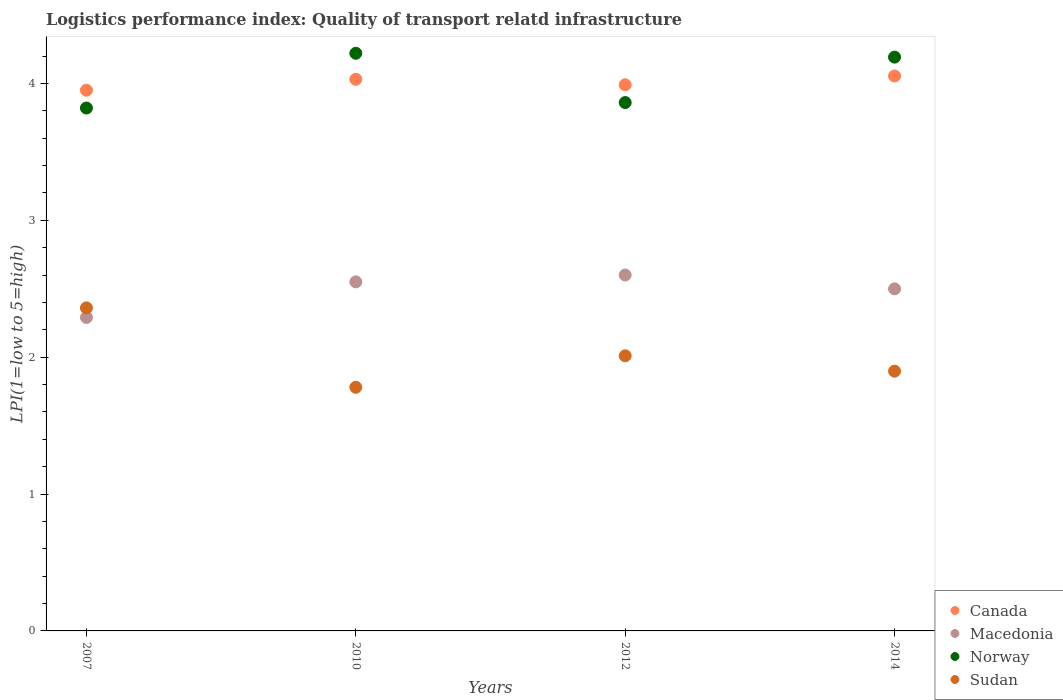How many different coloured dotlines are there?
Make the answer very short. 4. Is the number of dotlines equal to the number of legend labels?
Offer a very short reply. Yes. What is the logistics performance index in Canada in 2012?
Your answer should be very brief. 3.99. Across all years, what is the maximum logistics performance index in Canada?
Offer a terse response. 4.05. Across all years, what is the minimum logistics performance index in Norway?
Provide a succinct answer. 3.82. In which year was the logistics performance index in Sudan maximum?
Your answer should be compact. 2007. What is the total logistics performance index in Norway in the graph?
Your answer should be very brief. 16.09. What is the difference between the logistics performance index in Canada in 2007 and that in 2010?
Provide a short and direct response. -0.08. What is the difference between the logistics performance index in Norway in 2014 and the logistics performance index in Canada in 2012?
Offer a very short reply. 0.2. What is the average logistics performance index in Macedonia per year?
Your answer should be very brief. 2.48. In the year 2012, what is the difference between the logistics performance index in Macedonia and logistics performance index in Sudan?
Your answer should be compact. 0.59. In how many years, is the logistics performance index in Macedonia greater than 3.8?
Your response must be concise. 0. What is the ratio of the logistics performance index in Canada in 2007 to that in 2010?
Keep it short and to the point. 0.98. Is the logistics performance index in Norway in 2010 less than that in 2014?
Your answer should be compact. No. What is the difference between the highest and the second highest logistics performance index in Canada?
Your answer should be very brief. 0.02. What is the difference between the highest and the lowest logistics performance index in Sudan?
Offer a terse response. 0.58. In how many years, is the logistics performance index in Norway greater than the average logistics performance index in Norway taken over all years?
Provide a short and direct response. 2. Is the sum of the logistics performance index in Canada in 2010 and 2012 greater than the maximum logistics performance index in Norway across all years?
Your answer should be very brief. Yes. Is it the case that in every year, the sum of the logistics performance index in Canada and logistics performance index in Norway  is greater than the logistics performance index in Sudan?
Give a very brief answer. Yes. Is the logistics performance index in Norway strictly greater than the logistics performance index in Canada over the years?
Offer a terse response. No. How many dotlines are there?
Offer a very short reply. 4. How many years are there in the graph?
Offer a terse response. 4. Does the graph contain grids?
Ensure brevity in your answer.  No. Where does the legend appear in the graph?
Ensure brevity in your answer.  Bottom right. How are the legend labels stacked?
Keep it short and to the point. Vertical. What is the title of the graph?
Ensure brevity in your answer.  Logistics performance index: Quality of transport relatd infrastructure. Does "Ghana" appear as one of the legend labels in the graph?
Ensure brevity in your answer.  No. What is the label or title of the X-axis?
Keep it short and to the point. Years. What is the label or title of the Y-axis?
Offer a terse response. LPI(1=low to 5=high). What is the LPI(1=low to 5=high) of Canada in 2007?
Provide a succinct answer. 3.95. What is the LPI(1=low to 5=high) of Macedonia in 2007?
Provide a succinct answer. 2.29. What is the LPI(1=low to 5=high) in Norway in 2007?
Make the answer very short. 3.82. What is the LPI(1=low to 5=high) of Sudan in 2007?
Your answer should be very brief. 2.36. What is the LPI(1=low to 5=high) in Canada in 2010?
Offer a terse response. 4.03. What is the LPI(1=low to 5=high) in Macedonia in 2010?
Your answer should be compact. 2.55. What is the LPI(1=low to 5=high) of Norway in 2010?
Provide a succinct answer. 4.22. What is the LPI(1=low to 5=high) of Sudan in 2010?
Offer a terse response. 1.78. What is the LPI(1=low to 5=high) in Canada in 2012?
Provide a succinct answer. 3.99. What is the LPI(1=low to 5=high) of Macedonia in 2012?
Give a very brief answer. 2.6. What is the LPI(1=low to 5=high) of Norway in 2012?
Give a very brief answer. 3.86. What is the LPI(1=low to 5=high) in Sudan in 2012?
Provide a succinct answer. 2.01. What is the LPI(1=low to 5=high) in Canada in 2014?
Ensure brevity in your answer.  4.05. What is the LPI(1=low to 5=high) of Macedonia in 2014?
Offer a terse response. 2.5. What is the LPI(1=low to 5=high) in Norway in 2014?
Give a very brief answer. 4.19. What is the LPI(1=low to 5=high) of Sudan in 2014?
Offer a terse response. 1.9. Across all years, what is the maximum LPI(1=low to 5=high) in Canada?
Your answer should be compact. 4.05. Across all years, what is the maximum LPI(1=low to 5=high) of Macedonia?
Ensure brevity in your answer.  2.6. Across all years, what is the maximum LPI(1=low to 5=high) in Norway?
Ensure brevity in your answer.  4.22. Across all years, what is the maximum LPI(1=low to 5=high) in Sudan?
Offer a very short reply. 2.36. Across all years, what is the minimum LPI(1=low to 5=high) in Canada?
Your response must be concise. 3.95. Across all years, what is the minimum LPI(1=low to 5=high) of Macedonia?
Give a very brief answer. 2.29. Across all years, what is the minimum LPI(1=low to 5=high) in Norway?
Keep it short and to the point. 3.82. Across all years, what is the minimum LPI(1=low to 5=high) in Sudan?
Offer a very short reply. 1.78. What is the total LPI(1=low to 5=high) of Canada in the graph?
Provide a succinct answer. 16.02. What is the total LPI(1=low to 5=high) of Macedonia in the graph?
Give a very brief answer. 9.94. What is the total LPI(1=low to 5=high) in Norway in the graph?
Your answer should be compact. 16.09. What is the total LPI(1=low to 5=high) of Sudan in the graph?
Ensure brevity in your answer.  8.05. What is the difference between the LPI(1=low to 5=high) in Canada in 2007 and that in 2010?
Offer a terse response. -0.08. What is the difference between the LPI(1=low to 5=high) in Macedonia in 2007 and that in 2010?
Keep it short and to the point. -0.26. What is the difference between the LPI(1=low to 5=high) of Norway in 2007 and that in 2010?
Your answer should be very brief. -0.4. What is the difference between the LPI(1=low to 5=high) of Sudan in 2007 and that in 2010?
Make the answer very short. 0.58. What is the difference between the LPI(1=low to 5=high) of Canada in 2007 and that in 2012?
Provide a succinct answer. -0.04. What is the difference between the LPI(1=low to 5=high) in Macedonia in 2007 and that in 2012?
Offer a very short reply. -0.31. What is the difference between the LPI(1=low to 5=high) in Norway in 2007 and that in 2012?
Keep it short and to the point. -0.04. What is the difference between the LPI(1=low to 5=high) of Canada in 2007 and that in 2014?
Your response must be concise. -0.1. What is the difference between the LPI(1=low to 5=high) of Macedonia in 2007 and that in 2014?
Provide a short and direct response. -0.21. What is the difference between the LPI(1=low to 5=high) in Norway in 2007 and that in 2014?
Make the answer very short. -0.37. What is the difference between the LPI(1=low to 5=high) of Sudan in 2007 and that in 2014?
Keep it short and to the point. 0.46. What is the difference between the LPI(1=low to 5=high) in Norway in 2010 and that in 2012?
Offer a very short reply. 0.36. What is the difference between the LPI(1=low to 5=high) in Sudan in 2010 and that in 2012?
Your answer should be very brief. -0.23. What is the difference between the LPI(1=low to 5=high) in Canada in 2010 and that in 2014?
Ensure brevity in your answer.  -0.02. What is the difference between the LPI(1=low to 5=high) of Macedonia in 2010 and that in 2014?
Provide a short and direct response. 0.05. What is the difference between the LPI(1=low to 5=high) of Norway in 2010 and that in 2014?
Your answer should be compact. 0.03. What is the difference between the LPI(1=low to 5=high) in Sudan in 2010 and that in 2014?
Your response must be concise. -0.12. What is the difference between the LPI(1=low to 5=high) in Canada in 2012 and that in 2014?
Ensure brevity in your answer.  -0.06. What is the difference between the LPI(1=low to 5=high) in Macedonia in 2012 and that in 2014?
Your answer should be compact. 0.1. What is the difference between the LPI(1=low to 5=high) in Norway in 2012 and that in 2014?
Give a very brief answer. -0.33. What is the difference between the LPI(1=low to 5=high) in Sudan in 2012 and that in 2014?
Provide a succinct answer. 0.11. What is the difference between the LPI(1=low to 5=high) in Canada in 2007 and the LPI(1=low to 5=high) in Macedonia in 2010?
Your response must be concise. 1.4. What is the difference between the LPI(1=low to 5=high) of Canada in 2007 and the LPI(1=low to 5=high) of Norway in 2010?
Provide a succinct answer. -0.27. What is the difference between the LPI(1=low to 5=high) of Canada in 2007 and the LPI(1=low to 5=high) of Sudan in 2010?
Your response must be concise. 2.17. What is the difference between the LPI(1=low to 5=high) of Macedonia in 2007 and the LPI(1=low to 5=high) of Norway in 2010?
Offer a terse response. -1.93. What is the difference between the LPI(1=low to 5=high) of Macedonia in 2007 and the LPI(1=low to 5=high) of Sudan in 2010?
Ensure brevity in your answer.  0.51. What is the difference between the LPI(1=low to 5=high) of Norway in 2007 and the LPI(1=low to 5=high) of Sudan in 2010?
Your answer should be very brief. 2.04. What is the difference between the LPI(1=low to 5=high) of Canada in 2007 and the LPI(1=low to 5=high) of Macedonia in 2012?
Ensure brevity in your answer.  1.35. What is the difference between the LPI(1=low to 5=high) in Canada in 2007 and the LPI(1=low to 5=high) in Norway in 2012?
Your answer should be compact. 0.09. What is the difference between the LPI(1=low to 5=high) of Canada in 2007 and the LPI(1=low to 5=high) of Sudan in 2012?
Make the answer very short. 1.94. What is the difference between the LPI(1=low to 5=high) in Macedonia in 2007 and the LPI(1=low to 5=high) in Norway in 2012?
Your answer should be compact. -1.57. What is the difference between the LPI(1=low to 5=high) of Macedonia in 2007 and the LPI(1=low to 5=high) of Sudan in 2012?
Provide a short and direct response. 0.28. What is the difference between the LPI(1=low to 5=high) of Norway in 2007 and the LPI(1=low to 5=high) of Sudan in 2012?
Give a very brief answer. 1.81. What is the difference between the LPI(1=low to 5=high) of Canada in 2007 and the LPI(1=low to 5=high) of Macedonia in 2014?
Provide a succinct answer. 1.45. What is the difference between the LPI(1=low to 5=high) of Canada in 2007 and the LPI(1=low to 5=high) of Norway in 2014?
Provide a short and direct response. -0.24. What is the difference between the LPI(1=low to 5=high) of Canada in 2007 and the LPI(1=low to 5=high) of Sudan in 2014?
Give a very brief answer. 2.05. What is the difference between the LPI(1=low to 5=high) of Macedonia in 2007 and the LPI(1=low to 5=high) of Norway in 2014?
Give a very brief answer. -1.9. What is the difference between the LPI(1=low to 5=high) of Macedonia in 2007 and the LPI(1=low to 5=high) of Sudan in 2014?
Your answer should be very brief. 0.39. What is the difference between the LPI(1=low to 5=high) in Norway in 2007 and the LPI(1=low to 5=high) in Sudan in 2014?
Your answer should be compact. 1.92. What is the difference between the LPI(1=low to 5=high) in Canada in 2010 and the LPI(1=low to 5=high) in Macedonia in 2012?
Provide a succinct answer. 1.43. What is the difference between the LPI(1=low to 5=high) in Canada in 2010 and the LPI(1=low to 5=high) in Norway in 2012?
Provide a succinct answer. 0.17. What is the difference between the LPI(1=low to 5=high) of Canada in 2010 and the LPI(1=low to 5=high) of Sudan in 2012?
Give a very brief answer. 2.02. What is the difference between the LPI(1=low to 5=high) in Macedonia in 2010 and the LPI(1=low to 5=high) in Norway in 2012?
Your response must be concise. -1.31. What is the difference between the LPI(1=low to 5=high) of Macedonia in 2010 and the LPI(1=low to 5=high) of Sudan in 2012?
Your response must be concise. 0.54. What is the difference between the LPI(1=low to 5=high) of Norway in 2010 and the LPI(1=low to 5=high) of Sudan in 2012?
Keep it short and to the point. 2.21. What is the difference between the LPI(1=low to 5=high) of Canada in 2010 and the LPI(1=low to 5=high) of Macedonia in 2014?
Keep it short and to the point. 1.53. What is the difference between the LPI(1=low to 5=high) in Canada in 2010 and the LPI(1=low to 5=high) in Norway in 2014?
Give a very brief answer. -0.16. What is the difference between the LPI(1=low to 5=high) of Canada in 2010 and the LPI(1=low to 5=high) of Sudan in 2014?
Your answer should be very brief. 2.13. What is the difference between the LPI(1=low to 5=high) of Macedonia in 2010 and the LPI(1=low to 5=high) of Norway in 2014?
Your answer should be compact. -1.64. What is the difference between the LPI(1=low to 5=high) in Macedonia in 2010 and the LPI(1=low to 5=high) in Sudan in 2014?
Keep it short and to the point. 0.65. What is the difference between the LPI(1=low to 5=high) in Norway in 2010 and the LPI(1=low to 5=high) in Sudan in 2014?
Your answer should be very brief. 2.32. What is the difference between the LPI(1=low to 5=high) of Canada in 2012 and the LPI(1=low to 5=high) of Macedonia in 2014?
Offer a terse response. 1.49. What is the difference between the LPI(1=low to 5=high) in Canada in 2012 and the LPI(1=low to 5=high) in Norway in 2014?
Make the answer very short. -0.2. What is the difference between the LPI(1=low to 5=high) of Canada in 2012 and the LPI(1=low to 5=high) of Sudan in 2014?
Offer a very short reply. 2.09. What is the difference between the LPI(1=low to 5=high) in Macedonia in 2012 and the LPI(1=low to 5=high) in Norway in 2014?
Ensure brevity in your answer.  -1.59. What is the difference between the LPI(1=low to 5=high) in Macedonia in 2012 and the LPI(1=low to 5=high) in Sudan in 2014?
Keep it short and to the point. 0.7. What is the difference between the LPI(1=low to 5=high) in Norway in 2012 and the LPI(1=low to 5=high) in Sudan in 2014?
Provide a succinct answer. 1.96. What is the average LPI(1=low to 5=high) of Canada per year?
Make the answer very short. 4.01. What is the average LPI(1=low to 5=high) in Macedonia per year?
Provide a succinct answer. 2.48. What is the average LPI(1=low to 5=high) of Norway per year?
Your answer should be very brief. 4.02. What is the average LPI(1=low to 5=high) in Sudan per year?
Your response must be concise. 2.01. In the year 2007, what is the difference between the LPI(1=low to 5=high) of Canada and LPI(1=low to 5=high) of Macedonia?
Ensure brevity in your answer.  1.66. In the year 2007, what is the difference between the LPI(1=low to 5=high) in Canada and LPI(1=low to 5=high) in Norway?
Give a very brief answer. 0.13. In the year 2007, what is the difference between the LPI(1=low to 5=high) in Canada and LPI(1=low to 5=high) in Sudan?
Your answer should be compact. 1.59. In the year 2007, what is the difference between the LPI(1=low to 5=high) of Macedonia and LPI(1=low to 5=high) of Norway?
Your response must be concise. -1.53. In the year 2007, what is the difference between the LPI(1=low to 5=high) of Macedonia and LPI(1=low to 5=high) of Sudan?
Offer a very short reply. -0.07. In the year 2007, what is the difference between the LPI(1=low to 5=high) of Norway and LPI(1=low to 5=high) of Sudan?
Ensure brevity in your answer.  1.46. In the year 2010, what is the difference between the LPI(1=low to 5=high) in Canada and LPI(1=low to 5=high) in Macedonia?
Make the answer very short. 1.48. In the year 2010, what is the difference between the LPI(1=low to 5=high) in Canada and LPI(1=low to 5=high) in Norway?
Ensure brevity in your answer.  -0.19. In the year 2010, what is the difference between the LPI(1=low to 5=high) of Canada and LPI(1=low to 5=high) of Sudan?
Provide a short and direct response. 2.25. In the year 2010, what is the difference between the LPI(1=low to 5=high) in Macedonia and LPI(1=low to 5=high) in Norway?
Give a very brief answer. -1.67. In the year 2010, what is the difference between the LPI(1=low to 5=high) of Macedonia and LPI(1=low to 5=high) of Sudan?
Provide a short and direct response. 0.77. In the year 2010, what is the difference between the LPI(1=low to 5=high) in Norway and LPI(1=low to 5=high) in Sudan?
Your response must be concise. 2.44. In the year 2012, what is the difference between the LPI(1=low to 5=high) in Canada and LPI(1=low to 5=high) in Macedonia?
Your response must be concise. 1.39. In the year 2012, what is the difference between the LPI(1=low to 5=high) in Canada and LPI(1=low to 5=high) in Norway?
Offer a terse response. 0.13. In the year 2012, what is the difference between the LPI(1=low to 5=high) in Canada and LPI(1=low to 5=high) in Sudan?
Your answer should be compact. 1.98. In the year 2012, what is the difference between the LPI(1=low to 5=high) in Macedonia and LPI(1=low to 5=high) in Norway?
Your answer should be very brief. -1.26. In the year 2012, what is the difference between the LPI(1=low to 5=high) of Macedonia and LPI(1=low to 5=high) of Sudan?
Your answer should be compact. 0.59. In the year 2012, what is the difference between the LPI(1=low to 5=high) of Norway and LPI(1=low to 5=high) of Sudan?
Offer a terse response. 1.85. In the year 2014, what is the difference between the LPI(1=low to 5=high) in Canada and LPI(1=low to 5=high) in Macedonia?
Give a very brief answer. 1.56. In the year 2014, what is the difference between the LPI(1=low to 5=high) in Canada and LPI(1=low to 5=high) in Norway?
Make the answer very short. -0.14. In the year 2014, what is the difference between the LPI(1=low to 5=high) of Canada and LPI(1=low to 5=high) of Sudan?
Your response must be concise. 2.16. In the year 2014, what is the difference between the LPI(1=low to 5=high) in Macedonia and LPI(1=low to 5=high) in Norway?
Offer a very short reply. -1.69. In the year 2014, what is the difference between the LPI(1=low to 5=high) in Macedonia and LPI(1=low to 5=high) in Sudan?
Your answer should be very brief. 0.6. In the year 2014, what is the difference between the LPI(1=low to 5=high) in Norway and LPI(1=low to 5=high) in Sudan?
Keep it short and to the point. 2.29. What is the ratio of the LPI(1=low to 5=high) in Canada in 2007 to that in 2010?
Offer a very short reply. 0.98. What is the ratio of the LPI(1=low to 5=high) in Macedonia in 2007 to that in 2010?
Your answer should be compact. 0.9. What is the ratio of the LPI(1=low to 5=high) of Norway in 2007 to that in 2010?
Offer a very short reply. 0.91. What is the ratio of the LPI(1=low to 5=high) of Sudan in 2007 to that in 2010?
Provide a succinct answer. 1.33. What is the ratio of the LPI(1=low to 5=high) in Macedonia in 2007 to that in 2012?
Keep it short and to the point. 0.88. What is the ratio of the LPI(1=low to 5=high) of Norway in 2007 to that in 2012?
Your answer should be compact. 0.99. What is the ratio of the LPI(1=low to 5=high) in Sudan in 2007 to that in 2012?
Provide a succinct answer. 1.17. What is the ratio of the LPI(1=low to 5=high) of Canada in 2007 to that in 2014?
Your answer should be very brief. 0.97. What is the ratio of the LPI(1=low to 5=high) in Macedonia in 2007 to that in 2014?
Make the answer very short. 0.92. What is the ratio of the LPI(1=low to 5=high) in Norway in 2007 to that in 2014?
Your response must be concise. 0.91. What is the ratio of the LPI(1=low to 5=high) of Sudan in 2007 to that in 2014?
Offer a terse response. 1.24. What is the ratio of the LPI(1=low to 5=high) in Canada in 2010 to that in 2012?
Your answer should be very brief. 1.01. What is the ratio of the LPI(1=low to 5=high) in Macedonia in 2010 to that in 2012?
Ensure brevity in your answer.  0.98. What is the ratio of the LPI(1=low to 5=high) of Norway in 2010 to that in 2012?
Offer a terse response. 1.09. What is the ratio of the LPI(1=low to 5=high) in Sudan in 2010 to that in 2012?
Your answer should be very brief. 0.89. What is the ratio of the LPI(1=low to 5=high) of Canada in 2010 to that in 2014?
Offer a terse response. 0.99. What is the ratio of the LPI(1=low to 5=high) in Macedonia in 2010 to that in 2014?
Provide a succinct answer. 1.02. What is the ratio of the LPI(1=low to 5=high) of Norway in 2010 to that in 2014?
Keep it short and to the point. 1.01. What is the ratio of the LPI(1=low to 5=high) of Sudan in 2010 to that in 2014?
Offer a very short reply. 0.94. What is the ratio of the LPI(1=low to 5=high) of Canada in 2012 to that in 2014?
Provide a succinct answer. 0.98. What is the ratio of the LPI(1=low to 5=high) in Macedonia in 2012 to that in 2014?
Offer a terse response. 1.04. What is the ratio of the LPI(1=low to 5=high) of Norway in 2012 to that in 2014?
Ensure brevity in your answer.  0.92. What is the ratio of the LPI(1=low to 5=high) of Sudan in 2012 to that in 2014?
Give a very brief answer. 1.06. What is the difference between the highest and the second highest LPI(1=low to 5=high) in Canada?
Offer a very short reply. 0.02. What is the difference between the highest and the second highest LPI(1=low to 5=high) of Macedonia?
Give a very brief answer. 0.05. What is the difference between the highest and the second highest LPI(1=low to 5=high) in Norway?
Your response must be concise. 0.03. What is the difference between the highest and the lowest LPI(1=low to 5=high) in Canada?
Ensure brevity in your answer.  0.1. What is the difference between the highest and the lowest LPI(1=low to 5=high) of Macedonia?
Make the answer very short. 0.31. What is the difference between the highest and the lowest LPI(1=low to 5=high) of Sudan?
Your answer should be compact. 0.58. 